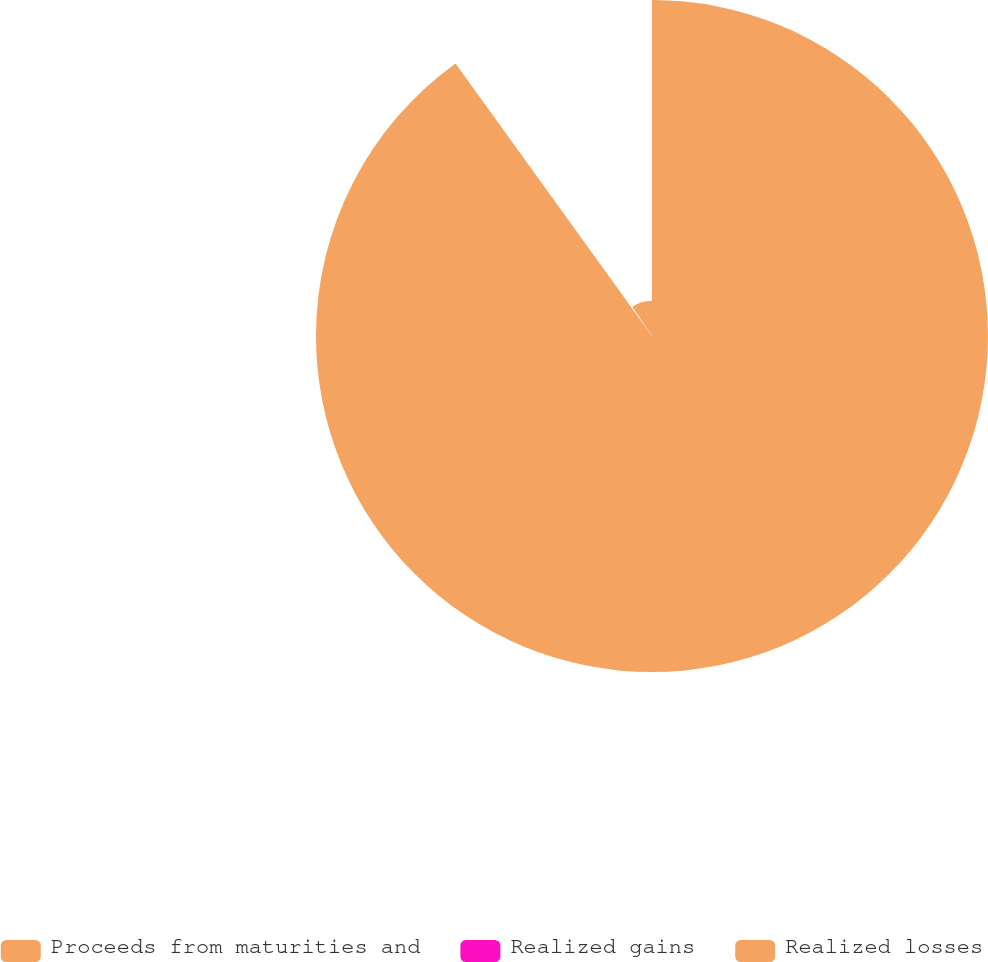Convert chart to OTSL. <chart><loc_0><loc_0><loc_500><loc_500><pie_chart><fcel>Proceeds from maturities and<fcel>Realized gains<fcel>Realized losses<nl><fcel>90.07%<fcel>0.49%<fcel>9.45%<nl></chart> 